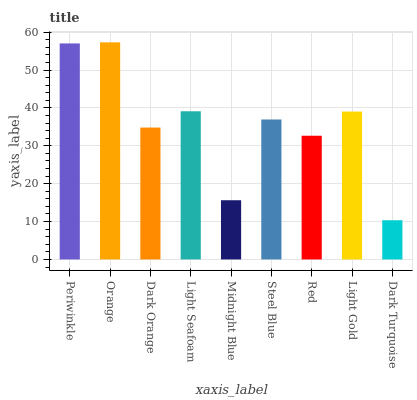Is Dark Turquoise the minimum?
Answer yes or no. Yes. Is Orange the maximum?
Answer yes or no. Yes. Is Dark Orange the minimum?
Answer yes or no. No. Is Dark Orange the maximum?
Answer yes or no. No. Is Orange greater than Dark Orange?
Answer yes or no. Yes. Is Dark Orange less than Orange?
Answer yes or no. Yes. Is Dark Orange greater than Orange?
Answer yes or no. No. Is Orange less than Dark Orange?
Answer yes or no. No. Is Steel Blue the high median?
Answer yes or no. Yes. Is Steel Blue the low median?
Answer yes or no. Yes. Is Midnight Blue the high median?
Answer yes or no. No. Is Dark Orange the low median?
Answer yes or no. No. 